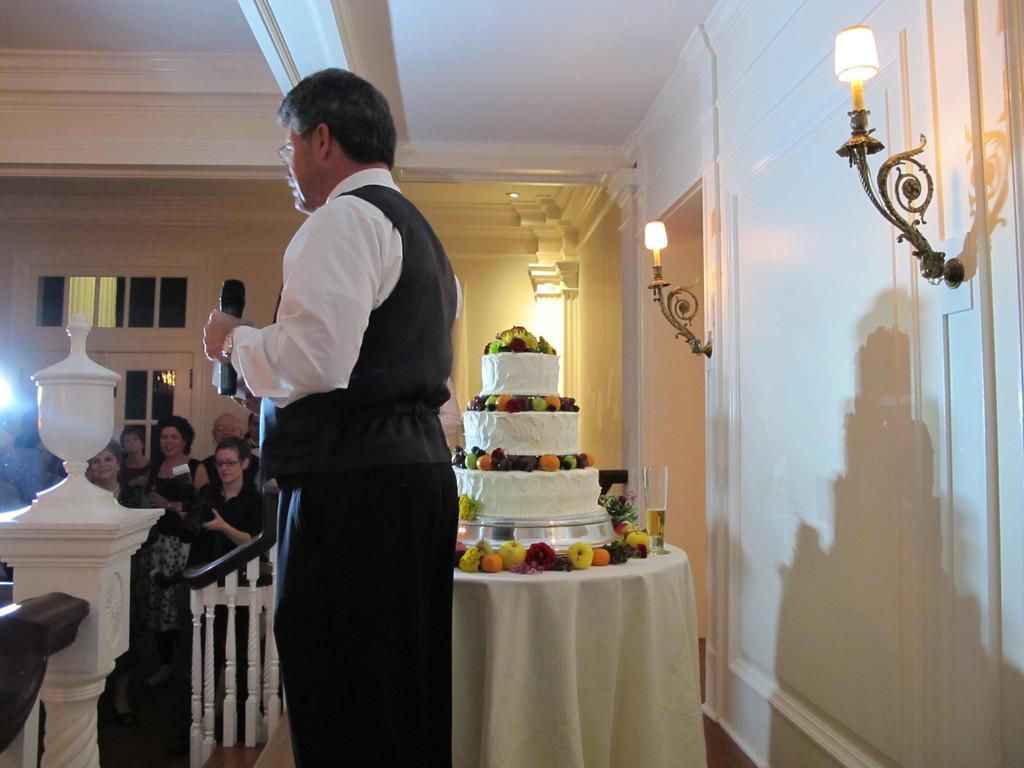Describe this image in one or two sentences. In this image, we can see a person is holding a microphone and object. Here we can see cake, few eatable things and glass with liquid are placed on the table. This table is covered with cloth. On the right side of the image, we can see walls, lights and stands. Left side of the image, we can see railings, stairs, door and a group of people. Here a woman is holding a camera. 